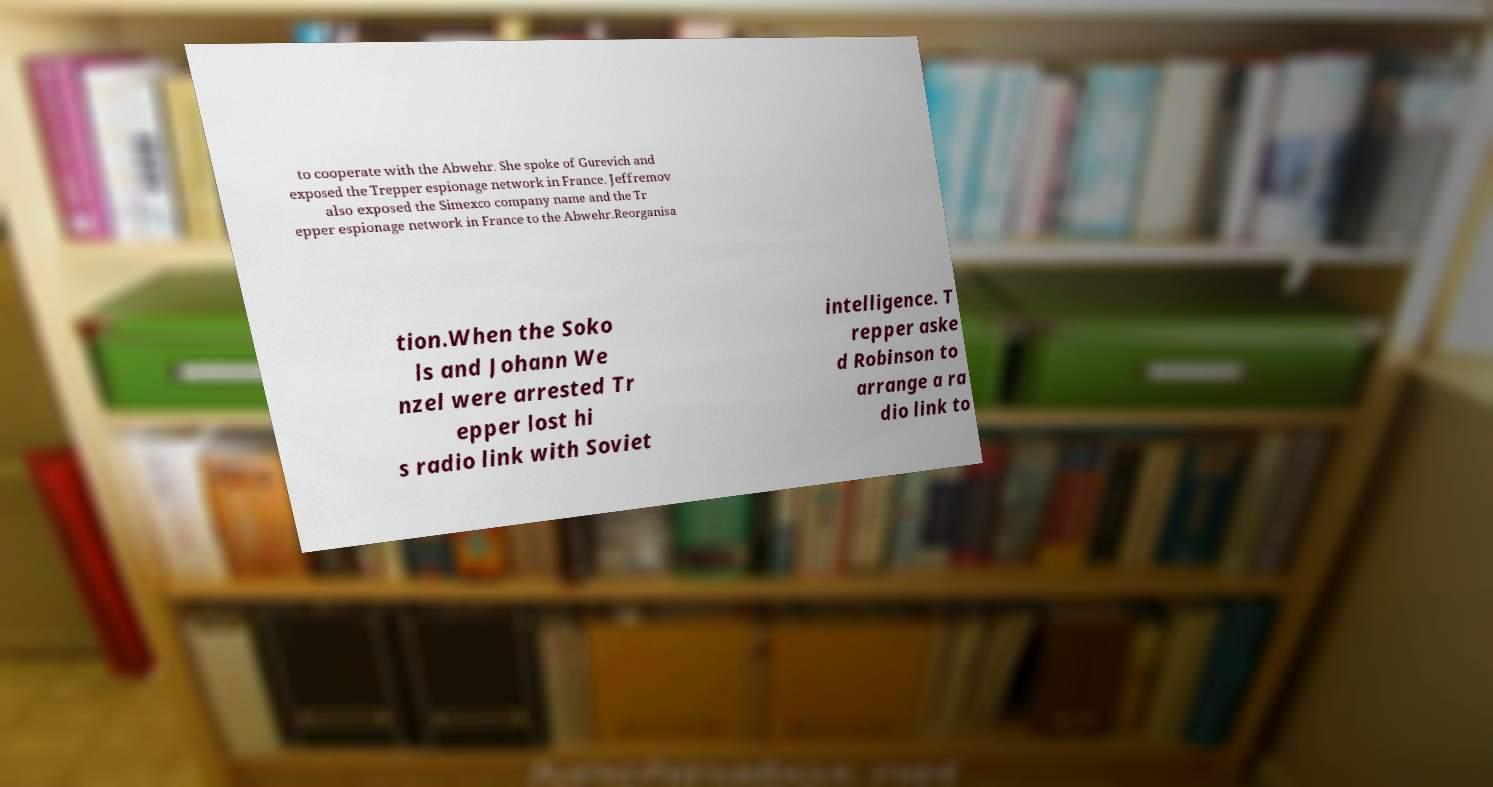Could you assist in decoding the text presented in this image and type it out clearly? to cooperate with the Abwehr. She spoke of Gurevich and exposed the Trepper espionage network in France. Jeffremov also exposed the Simexco company name and the Tr epper espionage network in France to the Abwehr.Reorganisa tion.When the Soko ls and Johann We nzel were arrested Tr epper lost hi s radio link with Soviet intelligence. T repper aske d Robinson to arrange a ra dio link to 